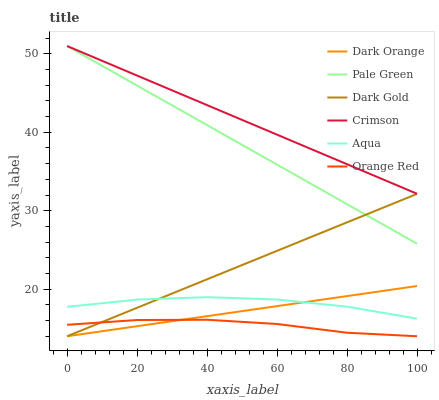Does Orange Red have the minimum area under the curve?
Answer yes or no. Yes. Does Crimson have the maximum area under the curve?
Answer yes or no. Yes. Does Dark Gold have the minimum area under the curve?
Answer yes or no. No. Does Dark Gold have the maximum area under the curve?
Answer yes or no. No. Is Pale Green the smoothest?
Answer yes or no. Yes. Is Aqua the roughest?
Answer yes or no. Yes. Is Dark Gold the smoothest?
Answer yes or no. No. Is Dark Gold the roughest?
Answer yes or no. No. Does Dark Orange have the lowest value?
Answer yes or no. Yes. Does Aqua have the lowest value?
Answer yes or no. No. Does Crimson have the highest value?
Answer yes or no. Yes. Does Dark Gold have the highest value?
Answer yes or no. No. Is Dark Orange less than Crimson?
Answer yes or no. Yes. Is Aqua greater than Orange Red?
Answer yes or no. Yes. Does Dark Orange intersect Dark Gold?
Answer yes or no. Yes. Is Dark Orange less than Dark Gold?
Answer yes or no. No. Is Dark Orange greater than Dark Gold?
Answer yes or no. No. Does Dark Orange intersect Crimson?
Answer yes or no. No. 